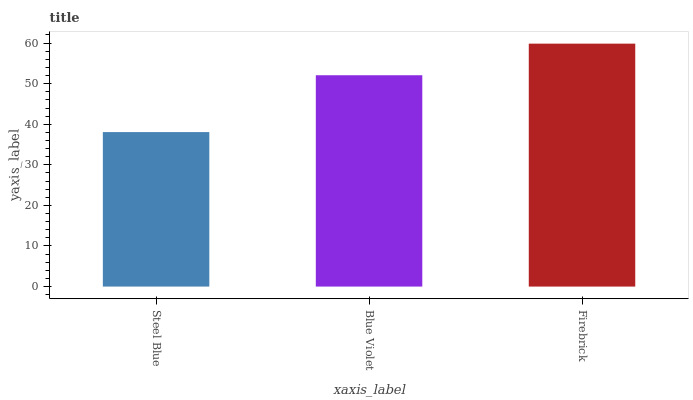Is Steel Blue the minimum?
Answer yes or no. Yes. Is Firebrick the maximum?
Answer yes or no. Yes. Is Blue Violet the minimum?
Answer yes or no. No. Is Blue Violet the maximum?
Answer yes or no. No. Is Blue Violet greater than Steel Blue?
Answer yes or no. Yes. Is Steel Blue less than Blue Violet?
Answer yes or no. Yes. Is Steel Blue greater than Blue Violet?
Answer yes or no. No. Is Blue Violet less than Steel Blue?
Answer yes or no. No. Is Blue Violet the high median?
Answer yes or no. Yes. Is Blue Violet the low median?
Answer yes or no. Yes. Is Firebrick the high median?
Answer yes or no. No. Is Steel Blue the low median?
Answer yes or no. No. 